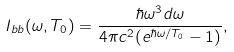<formula> <loc_0><loc_0><loc_500><loc_500>I _ { b b } ( \omega , T _ { 0 } ) = \frac { \hbar { \omega } ^ { 3 } d \omega } { 4 \pi c ^ { 2 } ( e ^ { \hbar { \omega } / T _ { 0 } } - 1 ) } ,</formula> 